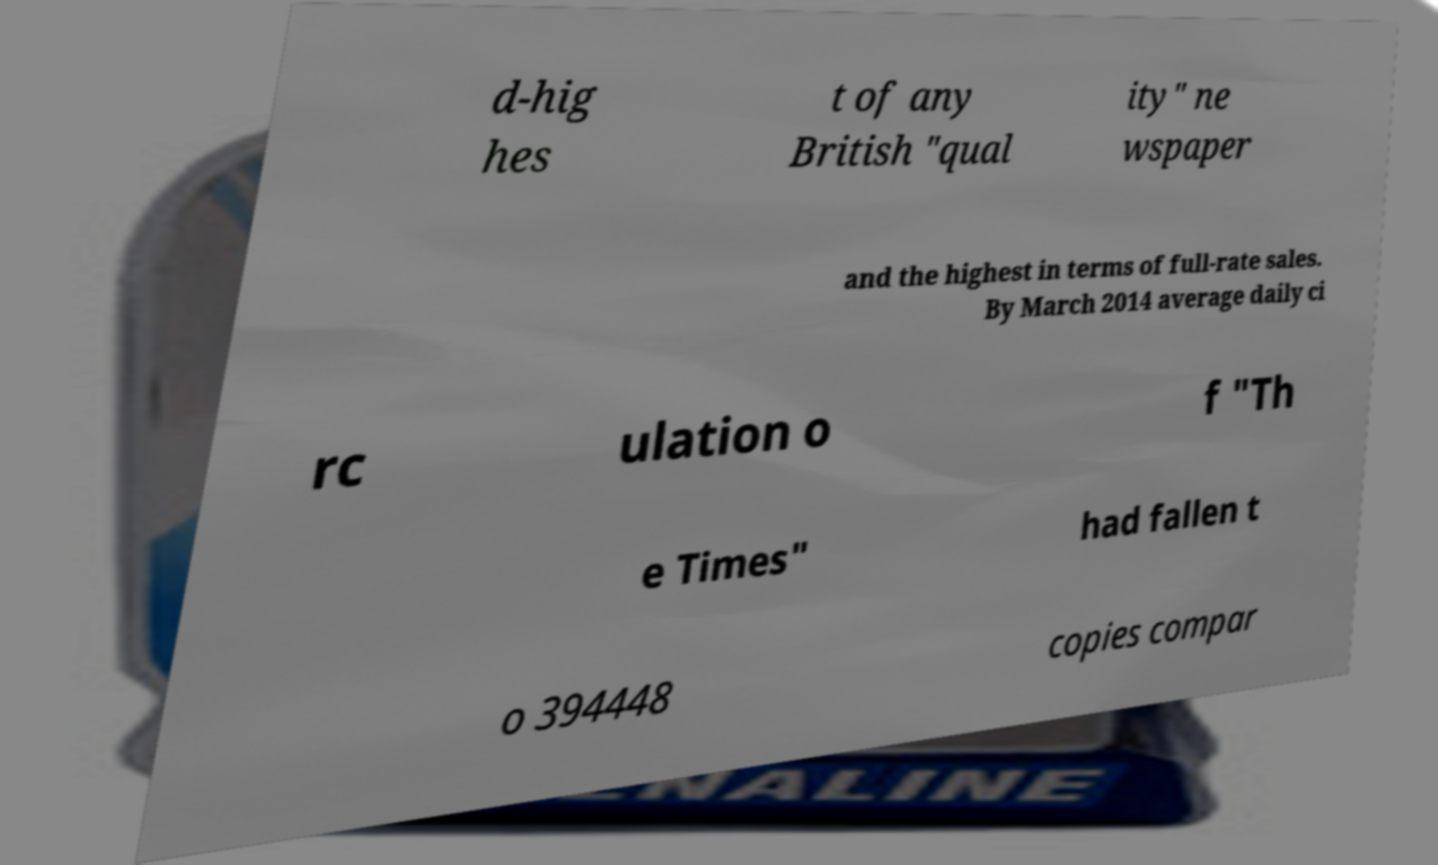Please read and relay the text visible in this image. What does it say? d-hig hes t of any British "qual ity" ne wspaper and the highest in terms of full-rate sales. By March 2014 average daily ci rc ulation o f "Th e Times" had fallen t o 394448 copies compar 